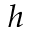Convert formula to latex. <formula><loc_0><loc_0><loc_500><loc_500>h</formula> 